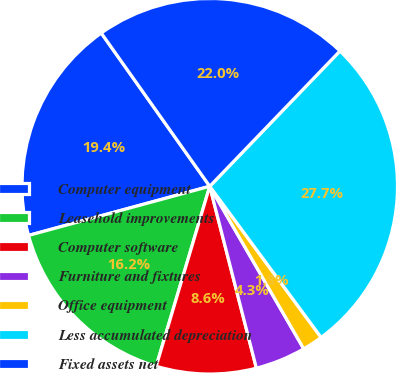Convert chart to OTSL. <chart><loc_0><loc_0><loc_500><loc_500><pie_chart><fcel>Computer equipment<fcel>Leasehold improvements<fcel>Computer software<fcel>Furniture and fixtures<fcel>Office equipment<fcel>Less accumulated depreciation<fcel>Fixed assets net<nl><fcel>19.41%<fcel>16.18%<fcel>8.6%<fcel>4.35%<fcel>1.76%<fcel>27.7%<fcel>22.0%<nl></chart> 